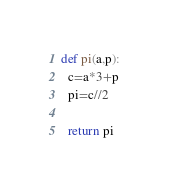<code> <loc_0><loc_0><loc_500><loc_500><_Python_>def pi(a,p):
  c=a*3+p
  pi=c//2
    
  return pi
</code> 